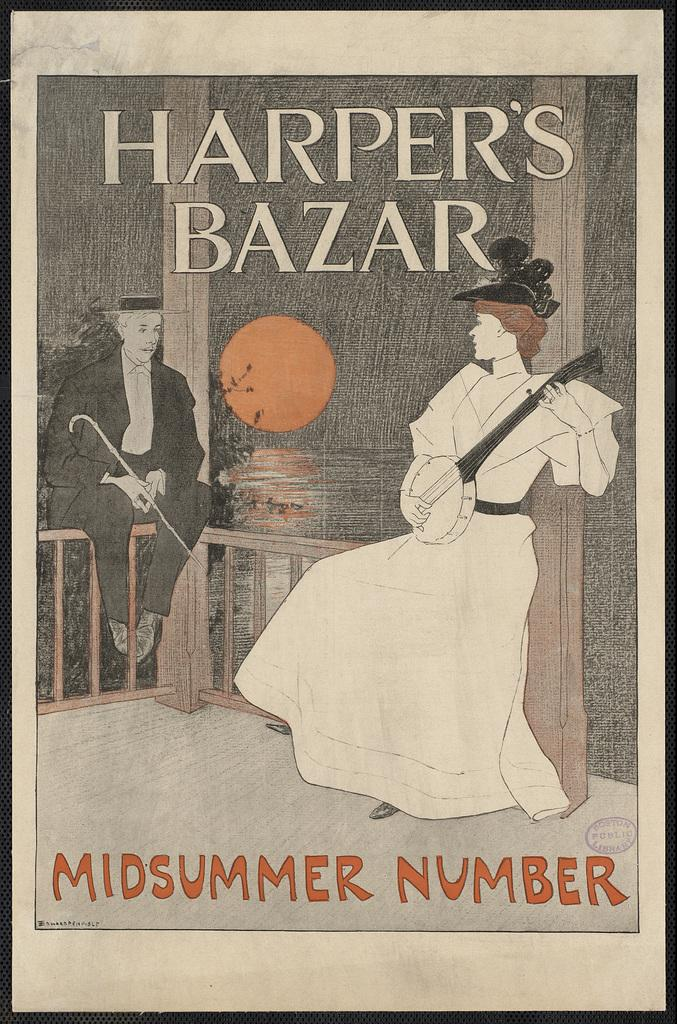What is present on the poster in the image? There is a poster in the image that contains two persons holding objects. What can be seen in the sky in the image? The sun is visible in the image. Are there any words or letters on the poster? Yes, there is text on the poster. What religious symbol is present on the poster? There is no religious symbol present on the poster; it contains two persons holding objects and text. What is the chance of winning a prize in the image? There is no indication of a prize or chance in the image; it features a poster with two persons holding objects, text, and the sun visible in the sky. 